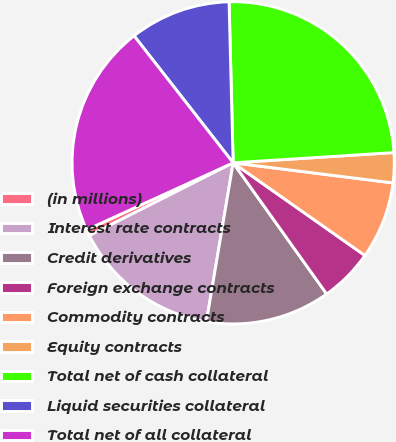Convert chart. <chart><loc_0><loc_0><loc_500><loc_500><pie_chart><fcel>(in millions)<fcel>Interest rate contracts<fcel>Credit derivatives<fcel>Foreign exchange contracts<fcel>Commodity contracts<fcel>Equity contracts<fcel>Total net of cash collateral<fcel>Liquid securities collateral<fcel>Total net of all collateral<nl><fcel>0.63%<fcel>14.89%<fcel>12.51%<fcel>5.39%<fcel>7.76%<fcel>3.01%<fcel>24.39%<fcel>10.14%<fcel>21.28%<nl></chart> 